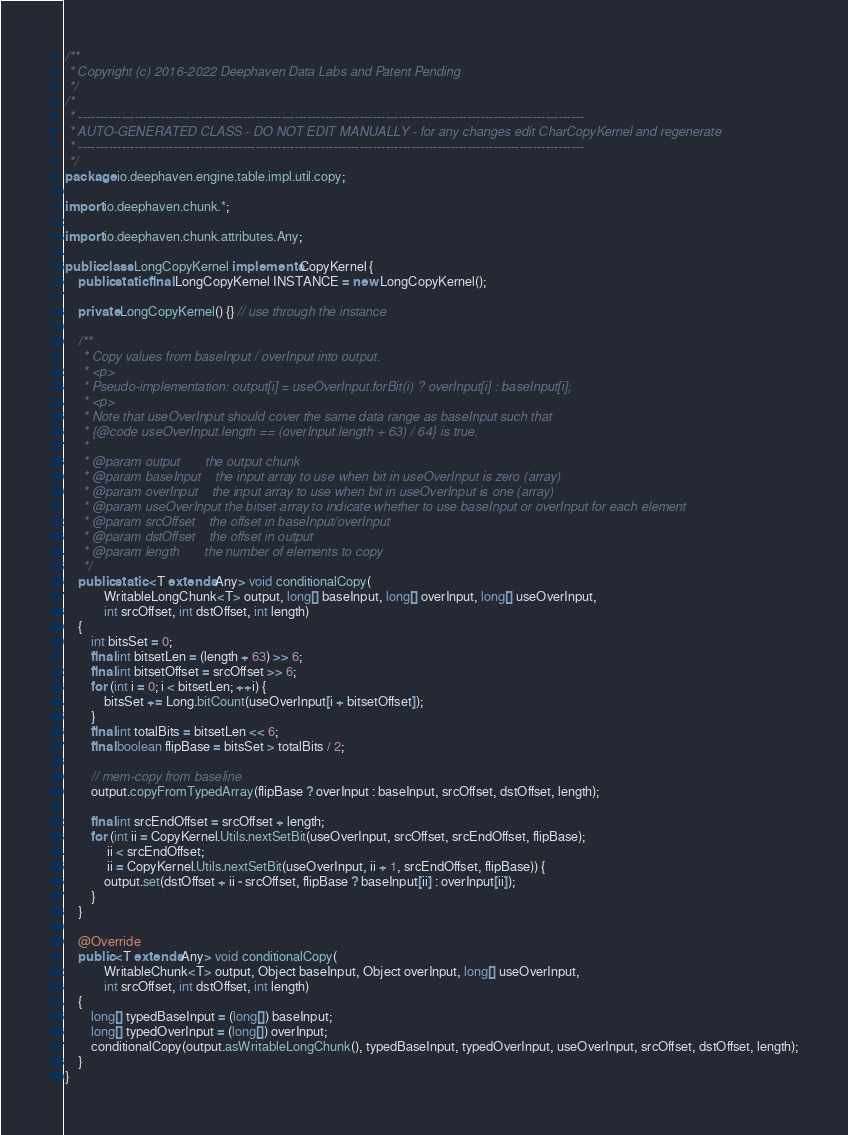<code> <loc_0><loc_0><loc_500><loc_500><_Java_>/**
 * Copyright (c) 2016-2022 Deephaven Data Labs and Patent Pending
 */
/*
 * ---------------------------------------------------------------------------------------------------------------------
 * AUTO-GENERATED CLASS - DO NOT EDIT MANUALLY - for any changes edit CharCopyKernel and regenerate
 * ---------------------------------------------------------------------------------------------------------------------
 */
package io.deephaven.engine.table.impl.util.copy;

import io.deephaven.chunk.*;

import io.deephaven.chunk.attributes.Any;

public class LongCopyKernel implements CopyKernel {
    public static final LongCopyKernel INSTANCE = new LongCopyKernel();

    private LongCopyKernel() {} // use through the instance

    /**
     * Copy values from baseInput / overInput into output.
     * <p>
     * Pseudo-implementation: output[i] = useOverInput.forBit(i) ? overInput[i] : baseInput[i];
     * <p>
     * Note that useOverInput should cover the same data range as baseInput such that
     * {@code useOverInput.length == (overInput.length + 63) / 64} is true.
     *
     * @param output       the output chunk
     * @param baseInput    the input array to use when bit in useOverInput is zero (array)
     * @param overInput    the input array to use when bit in useOverInput is one (array)
     * @param useOverInput the bitset array to indicate whether to use baseInput or overInput for each element
     * @param srcOffset    the offset in baseInput/overInput
     * @param dstOffset    the offset in output
     * @param length       the number of elements to copy
     */
    public static <T extends Any> void conditionalCopy(
            WritableLongChunk<T> output, long[] baseInput, long[] overInput, long[] useOverInput,
            int srcOffset, int dstOffset, int length)
    {
        int bitsSet = 0;
        final int bitsetLen = (length + 63) >> 6;
        final int bitsetOffset = srcOffset >> 6;
        for (int i = 0; i < bitsetLen; ++i) {
            bitsSet += Long.bitCount(useOverInput[i + bitsetOffset]);
        }
        final int totalBits = bitsetLen << 6;
        final boolean flipBase = bitsSet > totalBits / 2;

        // mem-copy from baseline
        output.copyFromTypedArray(flipBase ? overInput : baseInput, srcOffset, dstOffset, length);

        final int srcEndOffset = srcOffset + length;
        for (int ii = CopyKernel.Utils.nextSetBit(useOverInput, srcOffset, srcEndOffset, flipBase);
             ii < srcEndOffset;
             ii = CopyKernel.Utils.nextSetBit(useOverInput, ii + 1, srcEndOffset, flipBase)) {
            output.set(dstOffset + ii - srcOffset, flipBase ? baseInput[ii] : overInput[ii]);
        }
    }

    @Override
    public <T extends Any> void conditionalCopy(
            WritableChunk<T> output, Object baseInput, Object overInput, long[] useOverInput,
            int srcOffset, int dstOffset, int length)
    {
        long[] typedBaseInput = (long[]) baseInput;
        long[] typedOverInput = (long[]) overInput;
        conditionalCopy(output.asWritableLongChunk(), typedBaseInput, typedOverInput, useOverInput, srcOffset, dstOffset, length);
    }
}
</code> 